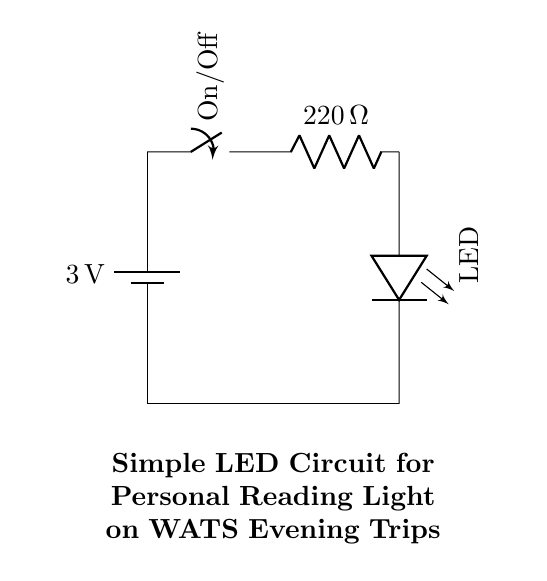What is the voltage of the battery in the circuit? The voltage of the battery is indicated as 3 volts, which is the power source for the entire circuit.
Answer: 3 volts What type of switch is used in this circuit? The circuit diagram shows a switch labeled as On/Off, indicating its function to control the flow of current.
Answer: On/Off What is the resistance value of the resistor? The resistor in the circuit is labeled with a resistance value of 220 ohms, which limits the current flowing through the LED.
Answer: 220 ohms How many components are in the circuit? The components consist of a battery, a switch, a resistor, and an LED, totaling four distinct parts.
Answer: Four Why is a resistor used in this circuit? A resistor is used to limit the current flowing to the LED to prevent damage, ensuring it operates within its safe limits.
Answer: To limit current What happens if the switch is turned off? If the switch is turned off, it breaks the circuit, causing the current to stop, which will turn off the LED light.
Answer: The LED turns off 